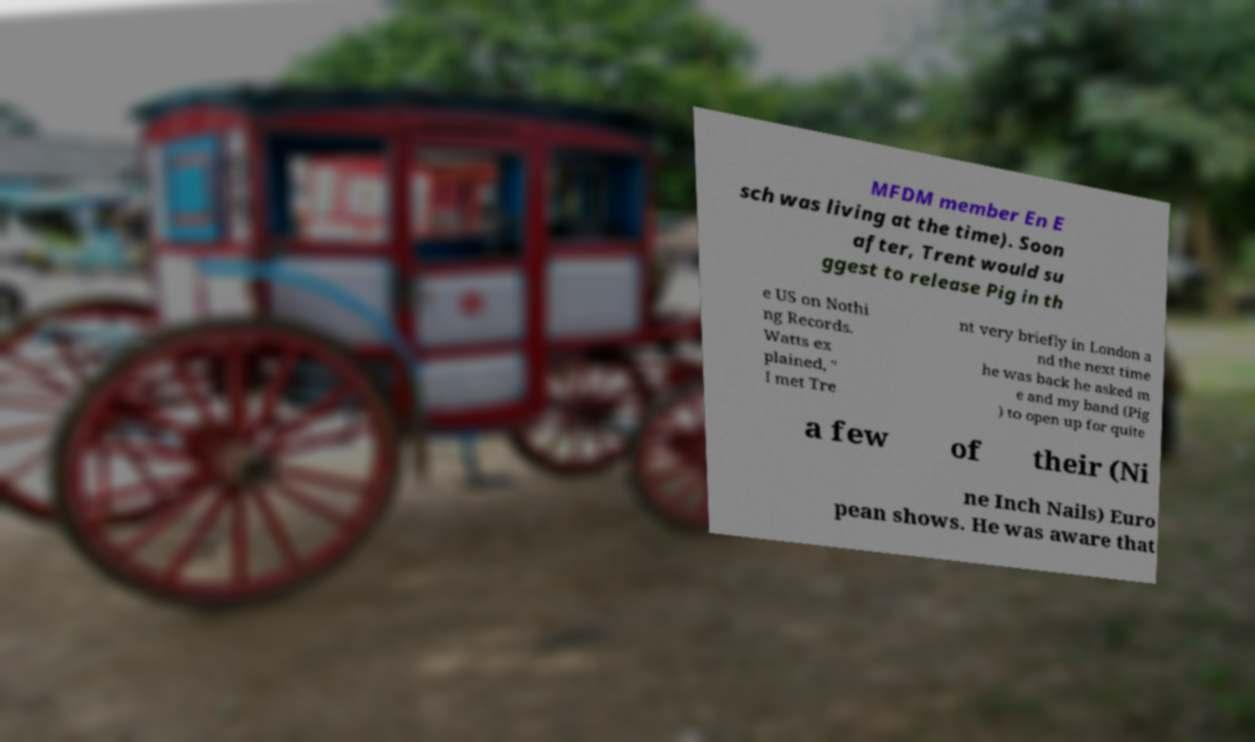Please identify and transcribe the text found in this image. MFDM member En E sch was living at the time). Soon after, Trent would su ggest to release Pig in th e US on Nothi ng Records. Watts ex plained, " I met Tre nt very briefly in London a nd the next time he was back he asked m e and my band (Pig ) to open up for quite a few of their (Ni ne Inch Nails) Euro pean shows. He was aware that 